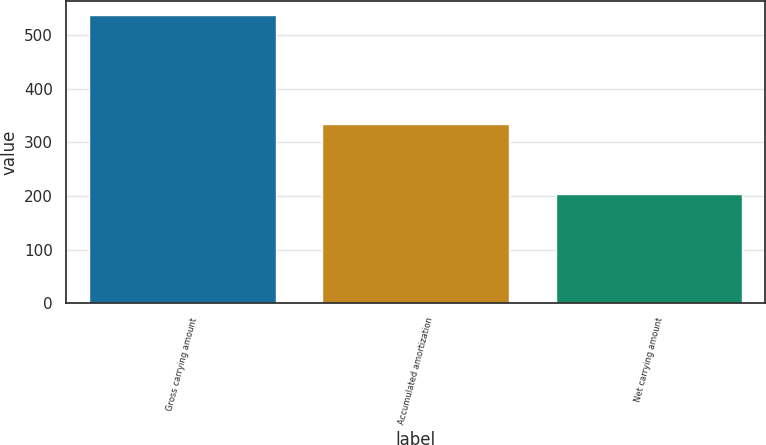Convert chart to OTSL. <chart><loc_0><loc_0><loc_500><loc_500><bar_chart><fcel>Gross carrying amount<fcel>Accumulated amortization<fcel>Net carrying amount<nl><fcel>538<fcel>334<fcel>204<nl></chart> 